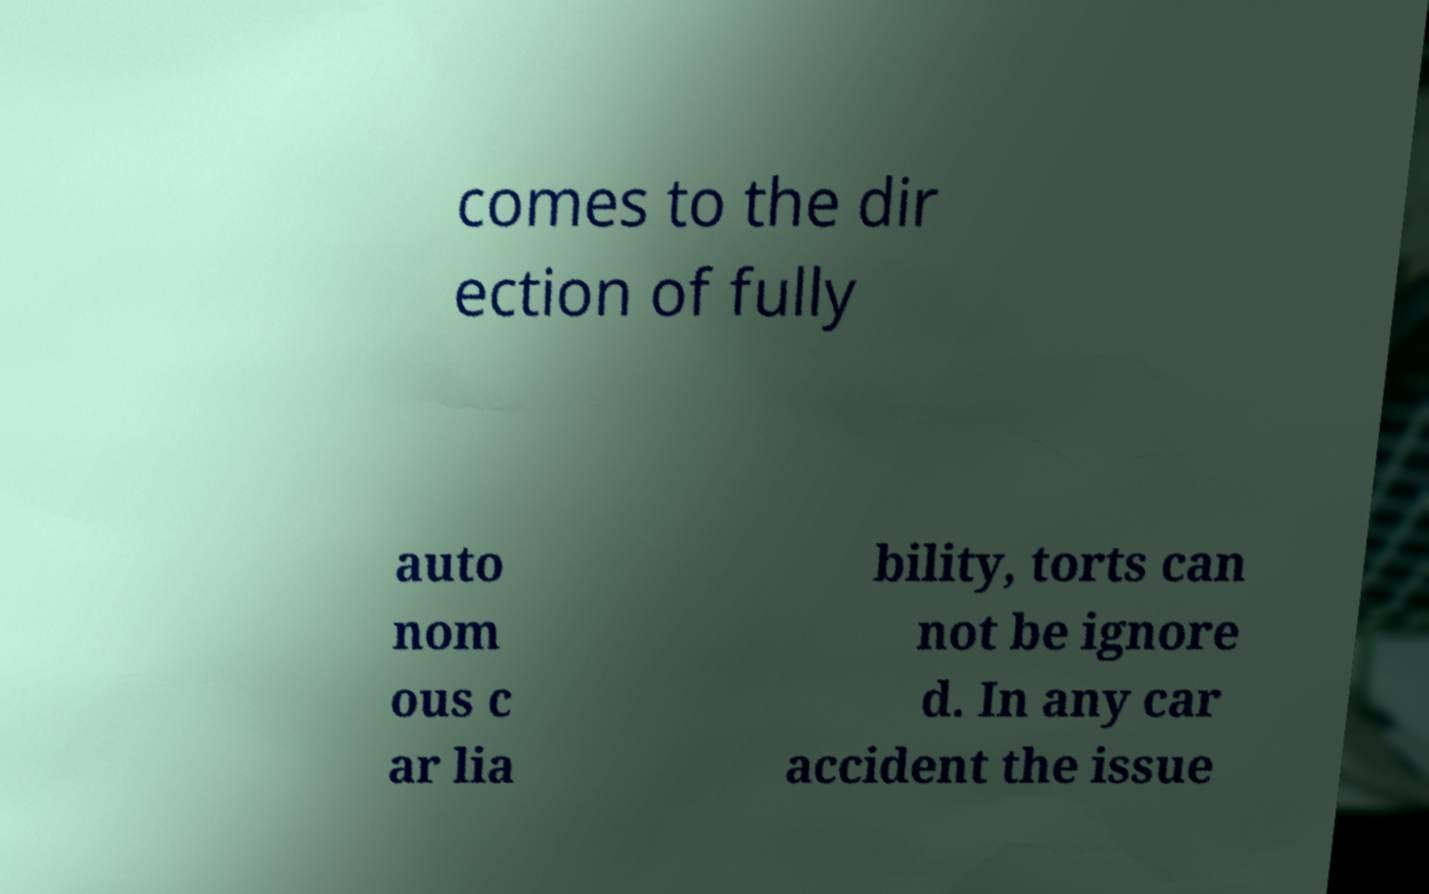Can you accurately transcribe the text from the provided image for me? comes to the dir ection of fully auto nom ous c ar lia bility, torts can not be ignore d. In any car accident the issue 